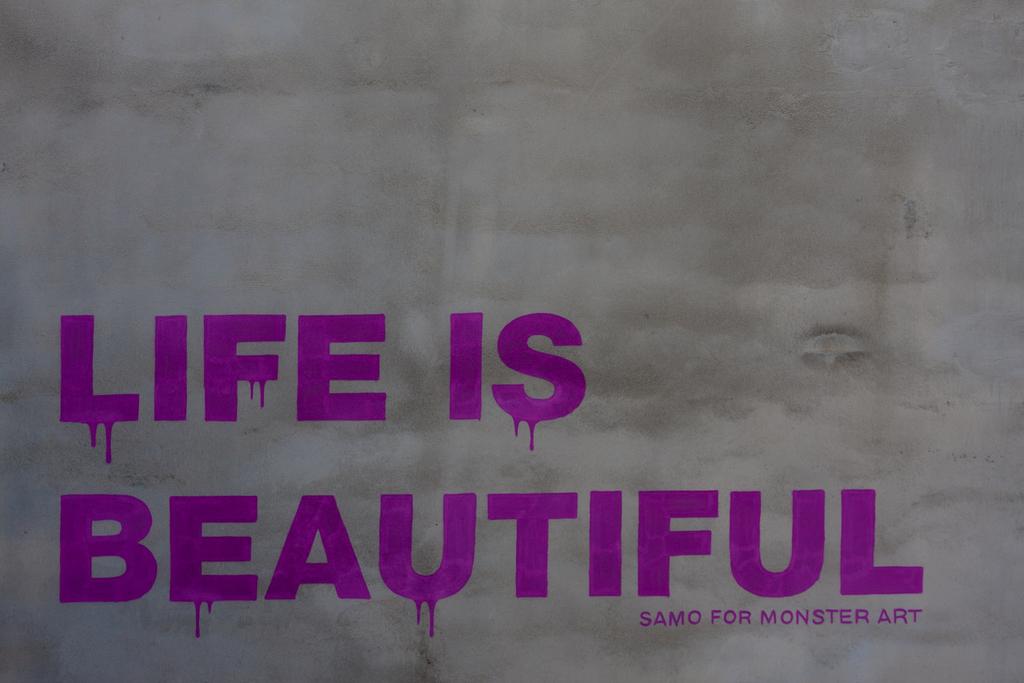What is life?
Provide a succinct answer. Beautiful. What is samo for?
Ensure brevity in your answer.  Monster art. 